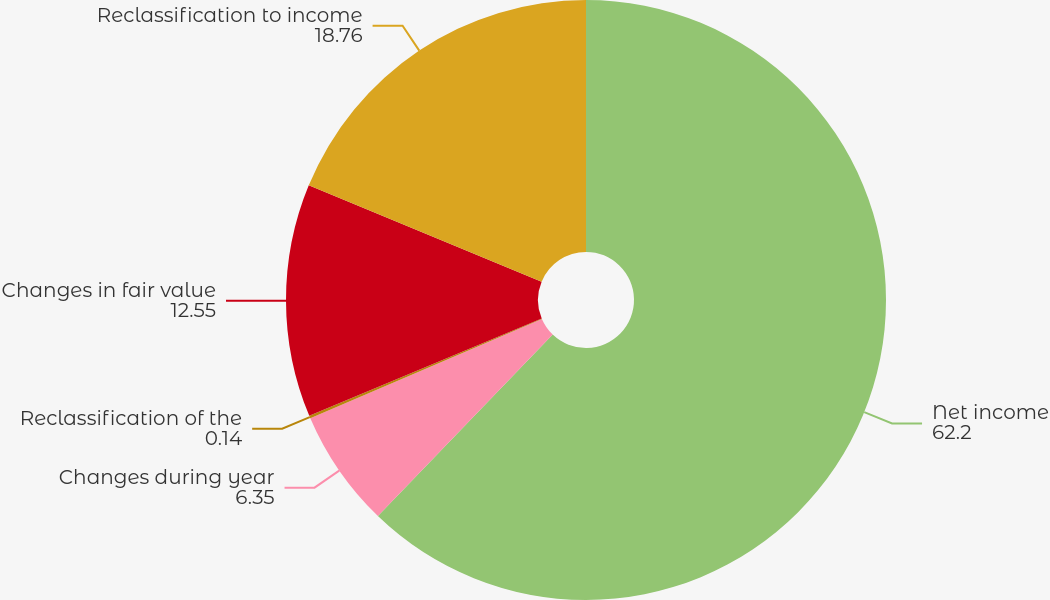<chart> <loc_0><loc_0><loc_500><loc_500><pie_chart><fcel>Net income<fcel>Changes during year<fcel>Reclassification of the<fcel>Changes in fair value<fcel>Reclassification to income<nl><fcel>62.2%<fcel>6.35%<fcel>0.14%<fcel>12.55%<fcel>18.76%<nl></chart> 